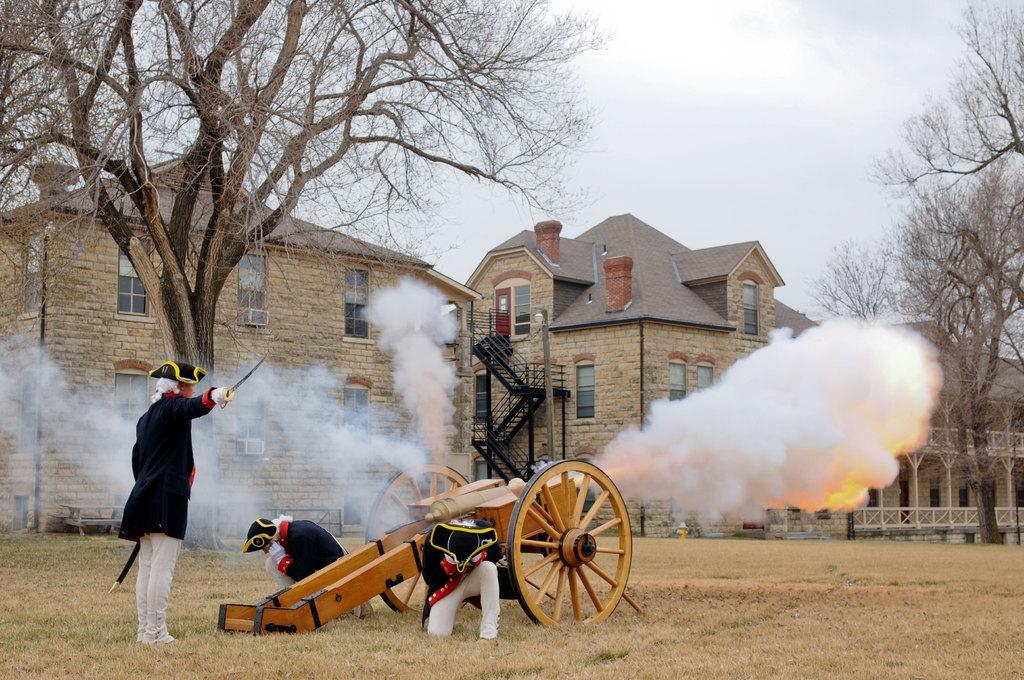Please provide a concise description of this image. This picture is taken from the outside of the city. In this image, on the left side, we can see a man standing and holding knife on one hand and some other objects on the other hand. In the middle of the image, we can see a war vehicle. In the middle of the image, we can also see another man is in squat position. In the middle, we can also see another person. On the right side, we can see some smoke. In the background, we can see a staircase, building, window, trees. At the top, we can see a sky which is cloudy, at the bottom, we can see a grass. 